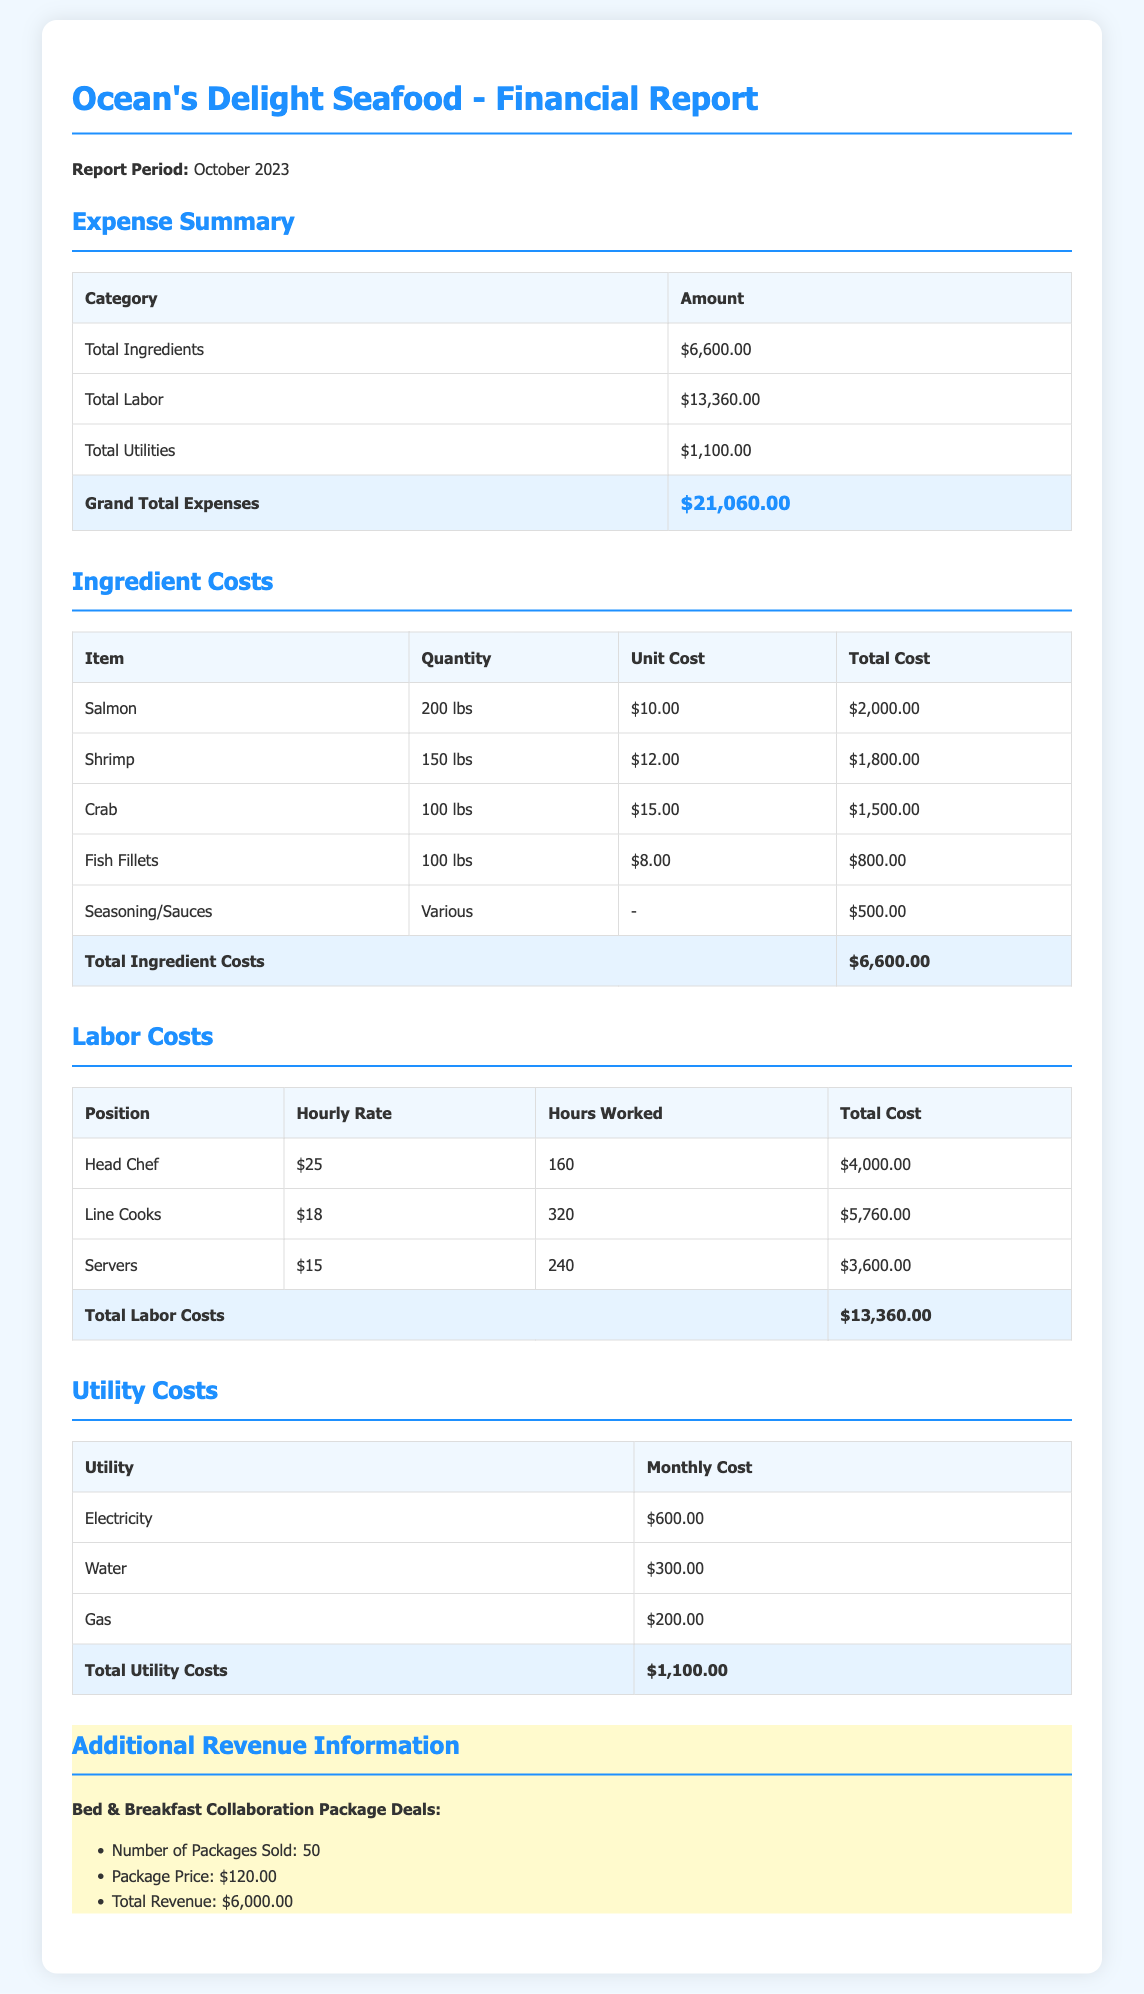what is the total cost of ingredients? The total cost of ingredients is clearly stated in the expense summary table.
Answer: $6,600.00 how much was spent on labor? The expense summary provides the total spent on labor.
Answer: $13,360.00 what is the total utility cost? The total utility cost is listed in the expense summary section of the report.
Answer: $1,100.00 what is the grand total of expenses? The grand total expenses are calculated and summarized in the report.
Answer: $21,060.00 how many packages were sold through the collaboration? The number of packages sold is mentioned under the additional revenue information.
Answer: 50 what was the package price for the collaboration? The package price is detailed in the additional revenue section.
Answer: $120.00 what was the total revenue generated from package deals? The total revenue from package deals is provided in the additional revenue information.
Answer: $6,000.00 how many hours did the Head Chef work? The hours worked by the Head Chef can be found in the labor costs table.
Answer: 160 what was the hourly rate for line cooks? The hourly rate for line cooks is specified in the labor costs table.
Answer: $18 